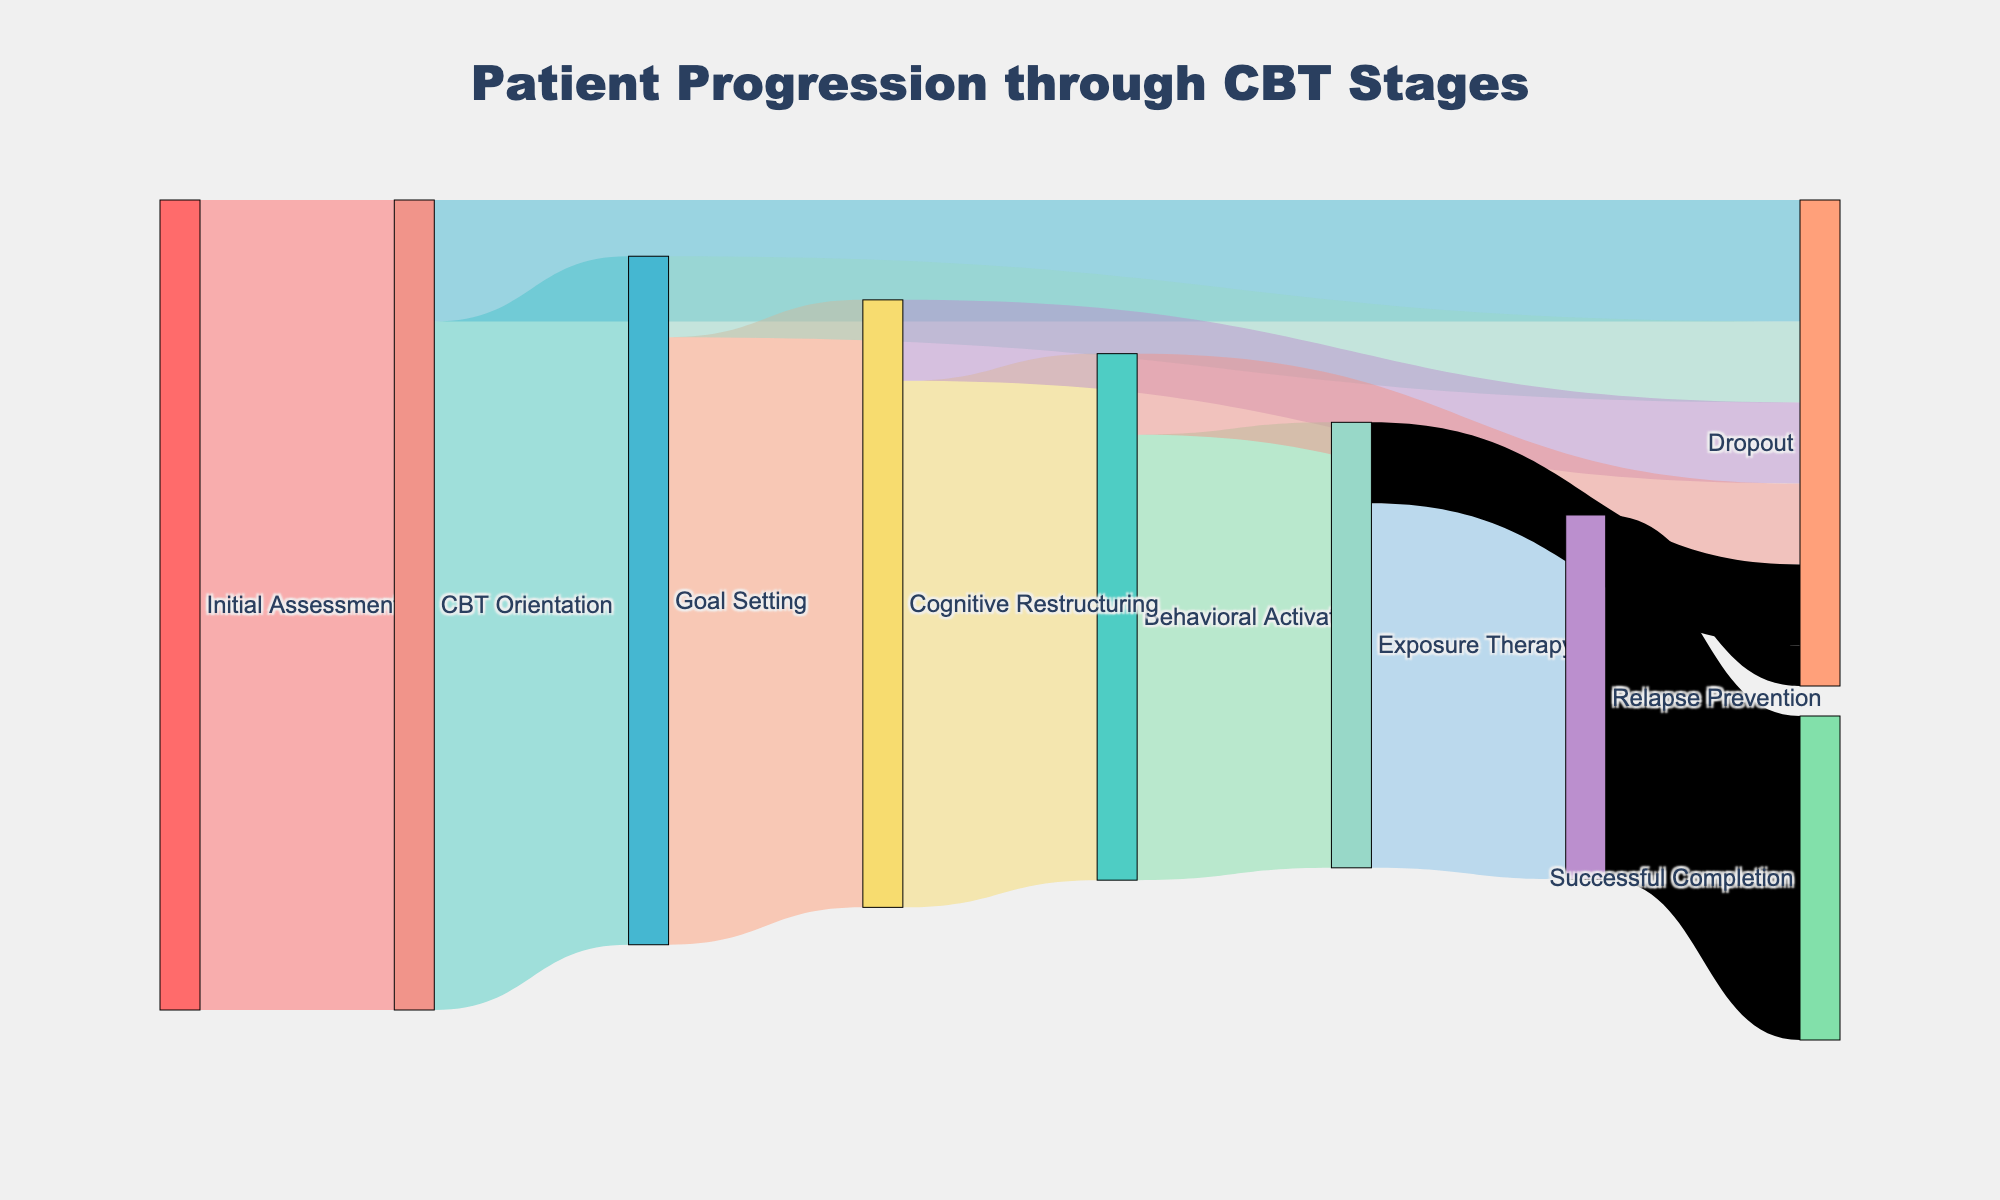What stage has the highest dropout rate? According to the figure, the stage with the highest dropout rate can be identified by seeing which stage has the largest flow labeled as "Dropout." The "CBT Orientation" stage has the highest dropout rate with 15 patients dropping out.
Answer: CBT Orientation How many patients completed the entire progression through CBT stages? To find this, look for the value linked to "Successful Completion." The figure shows a flow from "Relapse Prevention" to "Successful Completion" with a value of 40 patients.
Answer: 40 What is the total number of patients who dropped out during "Cognitive Restructuring"? The value directly flowing from "Cognitive Restructuring" to "Dropout" shows the number of dropouts. The Sankey diagram indicates that 10 patients dropped out during this stage.
Answer: 10 How many patients reached "Goal Setting"? To determine this, look for the flow entering the "Goal Setting" stage. The flow from "CBT Orientation" to "Goal Setting" shows a value of 85 patients.
Answer: 85 Compare the drop-out rates between "Behavioral Activation" and "Exposure Therapy". The dropout rate for "Behavioral Activation" is shown as a flow of 10 patients, while for "Exposure Therapy" it is also 10 patients. Both stages have the same dropout rate.
Answer: Equal What is the net progression to "Behavioral Activation"? To find this, subtract the number of dropouts from the total number entering the stage. From the diagram, 65 patients enter "Behavioral Activation," and 10 drop out. Thus, the net progression is 65 - 10 = 55 patients.
Answer: 55 How many patients were initially assessed? The initial number of patients assessed can be seen in the flow from "Initial Assessment" to "CBT Orientation," which shows a value of 100 patients.
Answer: 100 What is the ratio of patients who completed therapy to those who dropped out? To find this ratio, first, identify the number of patients who completed therapy (40) and those who dropped out (15+10+10+10+10+5 = 60). The ratio is calculated as 40/60 or 2/3.
Answer: 2/3 Which stage has the least number of remaining patients before the next stage? This can be determined by looking at the values between stages. The flow from "Exposure Therapy" to "Relapse Prevention" shows the least number of remaining patients with 45 individuals.
Answer: Exposure Therapy 